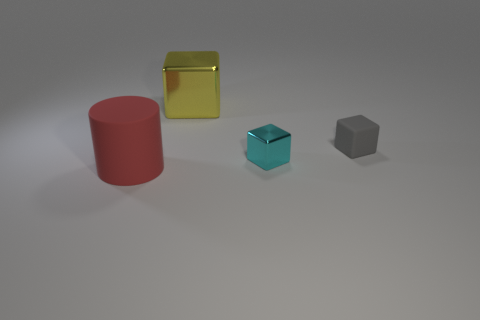Subtract all rubber blocks. How many blocks are left? 2 Subtract all cyan blocks. How many blocks are left? 2 Add 4 gray rubber things. How many objects exist? 8 Subtract all brown spheres. How many gray blocks are left? 1 Subtract all purple blocks. Subtract all purple cylinders. How many blocks are left? 3 Subtract all large yellow cubes. Subtract all purple spheres. How many objects are left? 3 Add 3 small gray rubber things. How many small gray rubber things are left? 4 Add 3 metal blocks. How many metal blocks exist? 5 Subtract 1 yellow blocks. How many objects are left? 3 Subtract all blocks. How many objects are left? 1 